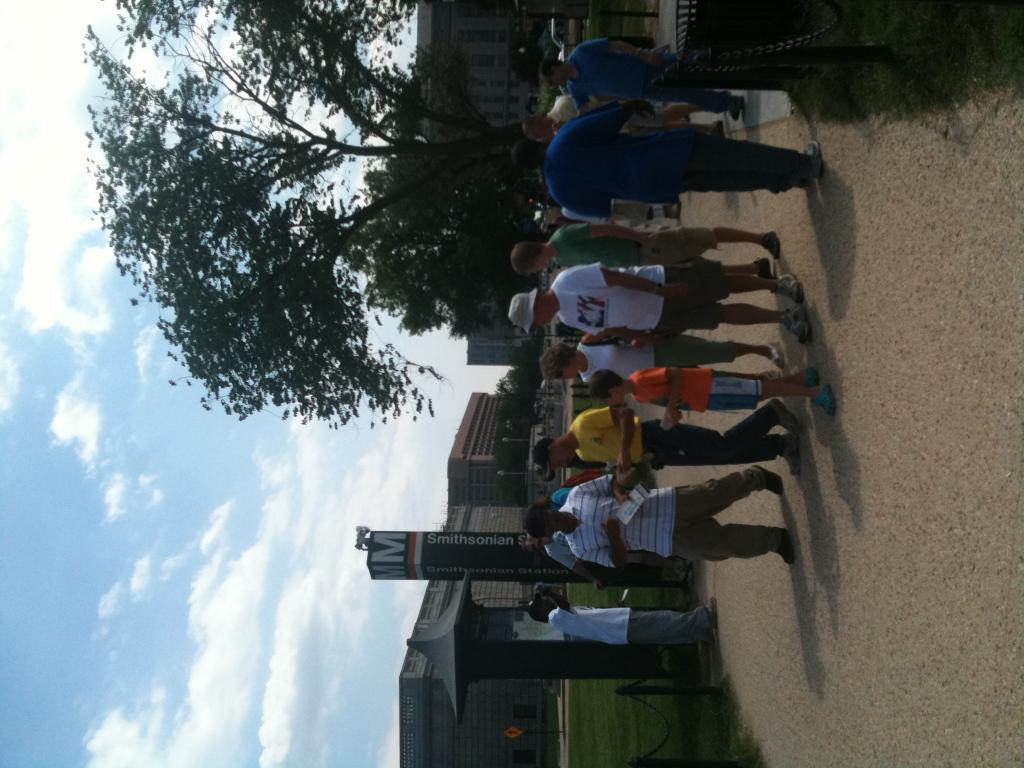What is happening on the road in the image? There is a group of people on the road in the image. What can be seen in the background of the image? There are buildings, trees, and the sky visible in the background of the image. What type of smell can be detected from the trucks in the image? There are no trucks present in the image, so it is not possible to determine any associated smells. 